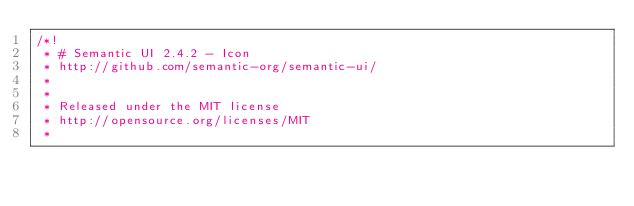Convert code to text. <code><loc_0><loc_0><loc_500><loc_500><_CSS_>/*!
 * # Semantic UI 2.4.2 - Icon
 * http://github.com/semantic-org/semantic-ui/
 *
 *
 * Released under the MIT license
 * http://opensource.org/licenses/MIT
 *</code> 